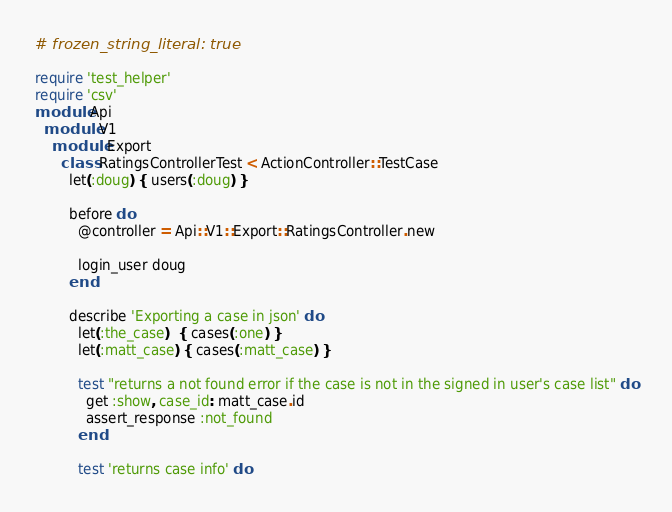Convert code to text. <code><loc_0><loc_0><loc_500><loc_500><_Ruby_># frozen_string_literal: true

require 'test_helper'
require 'csv'
module Api
  module V1
    module Export
      class RatingsControllerTest < ActionController::TestCase
        let(:doug) { users(:doug) }

        before do
          @controller = Api::V1::Export::RatingsController.new

          login_user doug
        end

        describe 'Exporting a case in json' do
          let(:the_case)  { cases(:one) }
          let(:matt_case) { cases(:matt_case) }

          test "returns a not found error if the case is not in the signed in user's case list" do
            get :show, case_id: matt_case.id
            assert_response :not_found
          end

          test 'returns case info' do</code> 